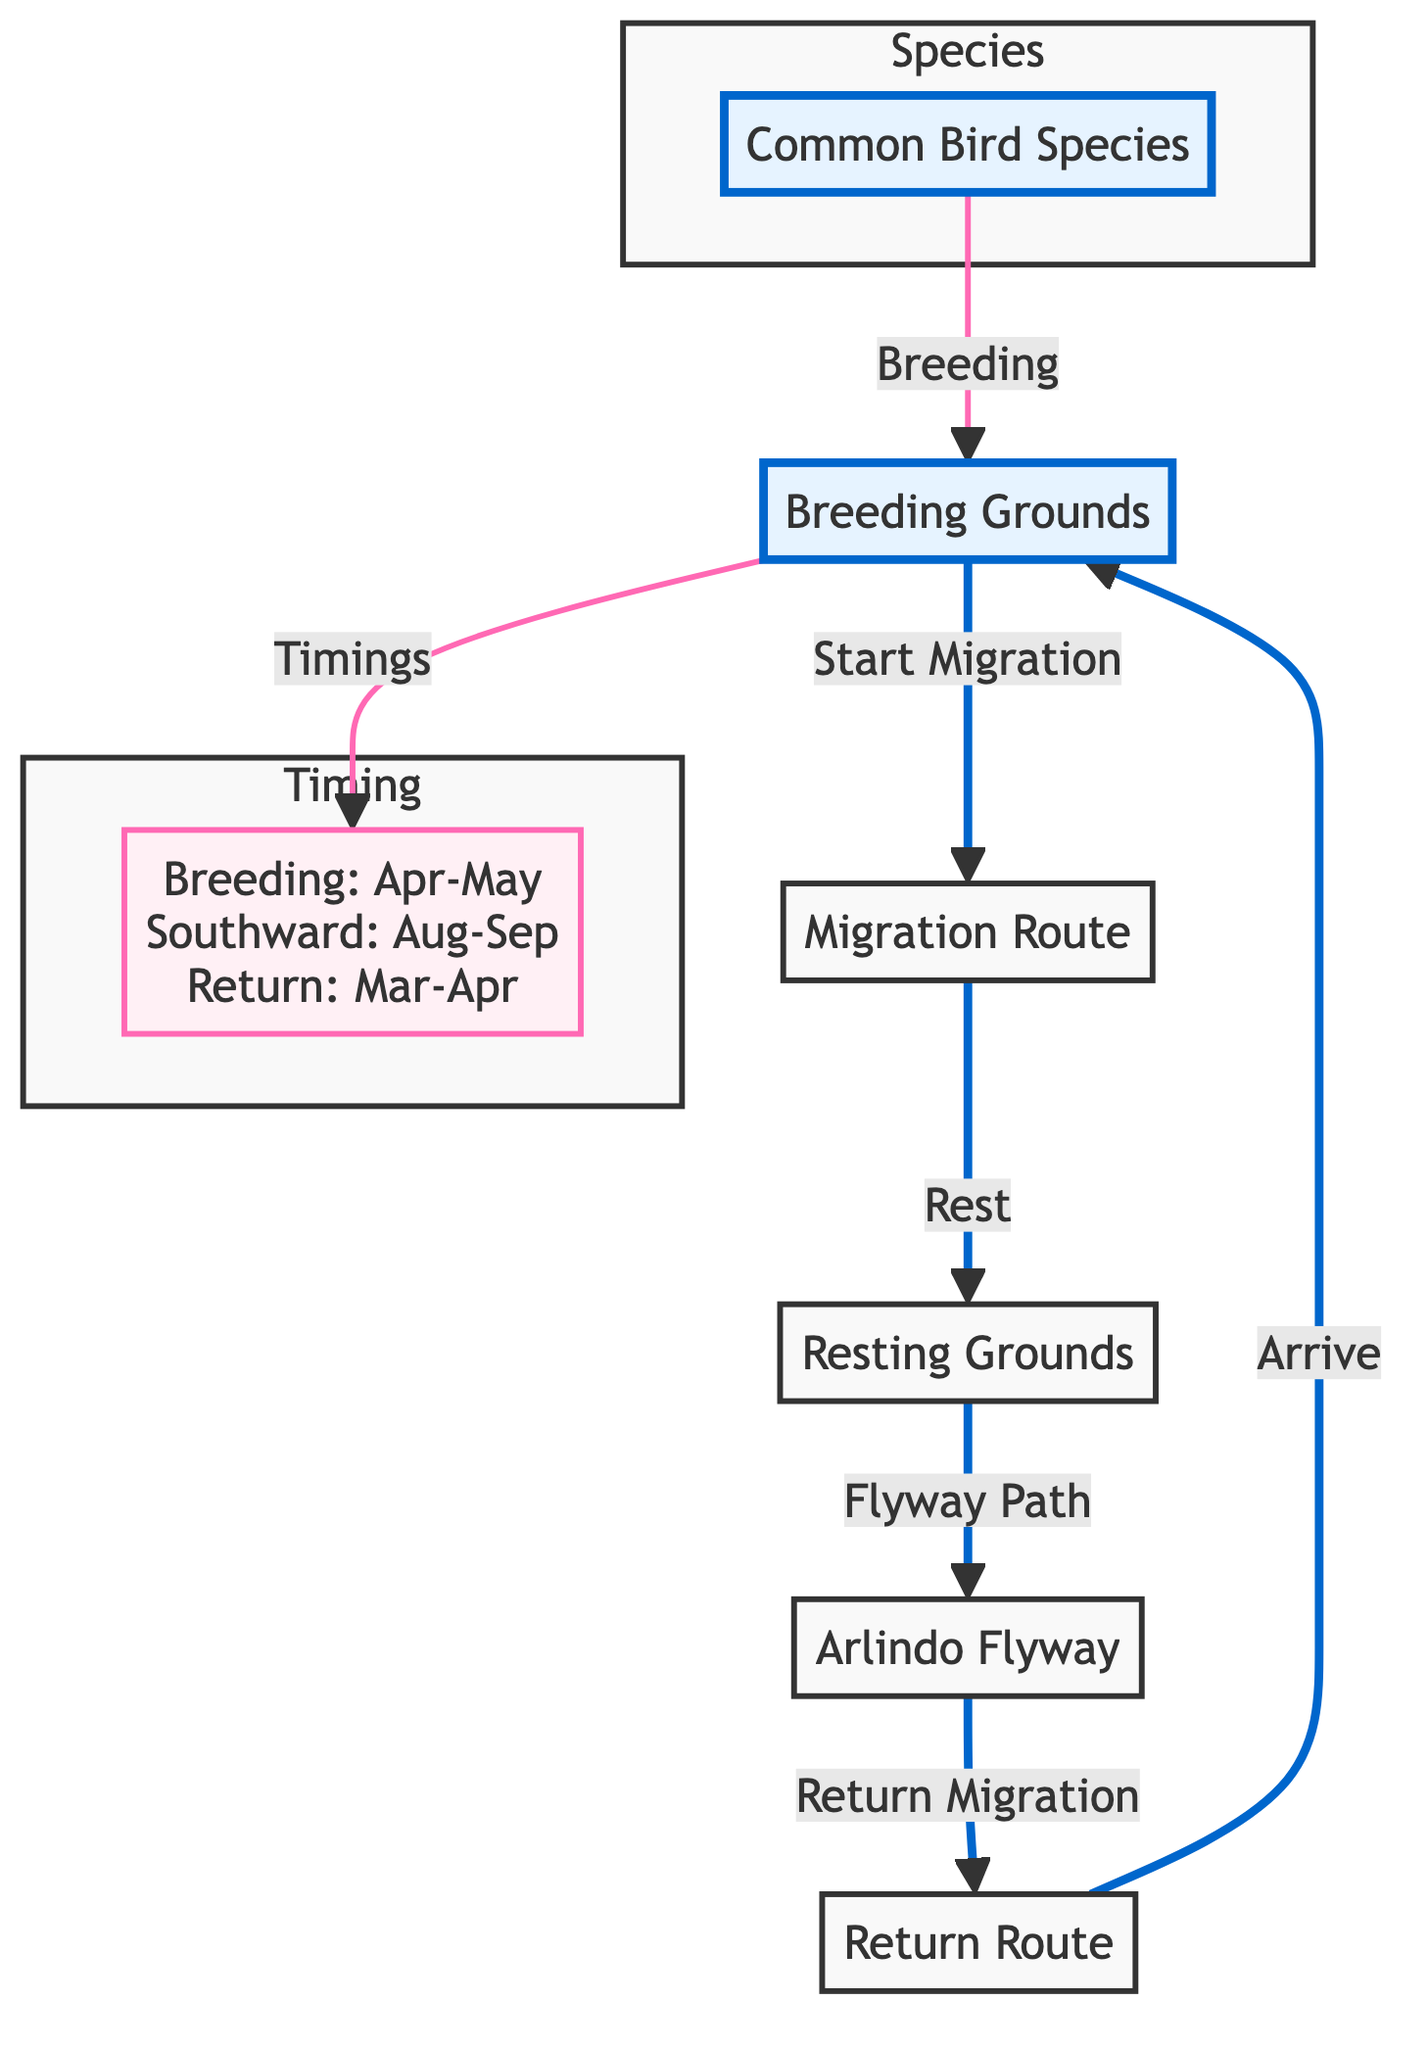What are the breeding ground months for the birds? The diagram indicates that breeding occurs from April to May as part of the details under "Breeding Grounds."
Answer: April-May How many migration routes are indicated in the diagram? The diagram shows a single migration route that connects breeding grounds to resting grounds, then to the flyway path and return routes.
Answer: 1 What is the timing for the southward migration? The diagram notes that the southward migration occurs in August to September under the "Migration Timing" section.
Answer: August-September What do birds do at resting grounds? The diagram states that at resting grounds, birds rest before continuing their migration as indicated in the flow from migration route to resting grounds.
Answer: Rest What is the significance of the Arlindo Flyway in the migration process? The Arlindo Flyway is depicted as the pathway that the birds follow towards the return migration, showing its importance in their migratory journey.
Answer: Flyway Path When do birds return to their breeding grounds? The diagram specifies that birds return to their breeding grounds in March to April, as stated in the "Migration Timing" section.
Answer: March-April 